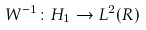Convert formula to latex. <formula><loc_0><loc_0><loc_500><loc_500>W ^ { - 1 } \colon H _ { 1 } \rightarrow L ^ { 2 } ( R )</formula> 